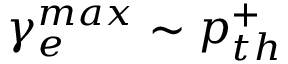<formula> <loc_0><loc_0><loc_500><loc_500>\gamma _ { e } ^ { \max } \sim p _ { t h } ^ { + }</formula> 